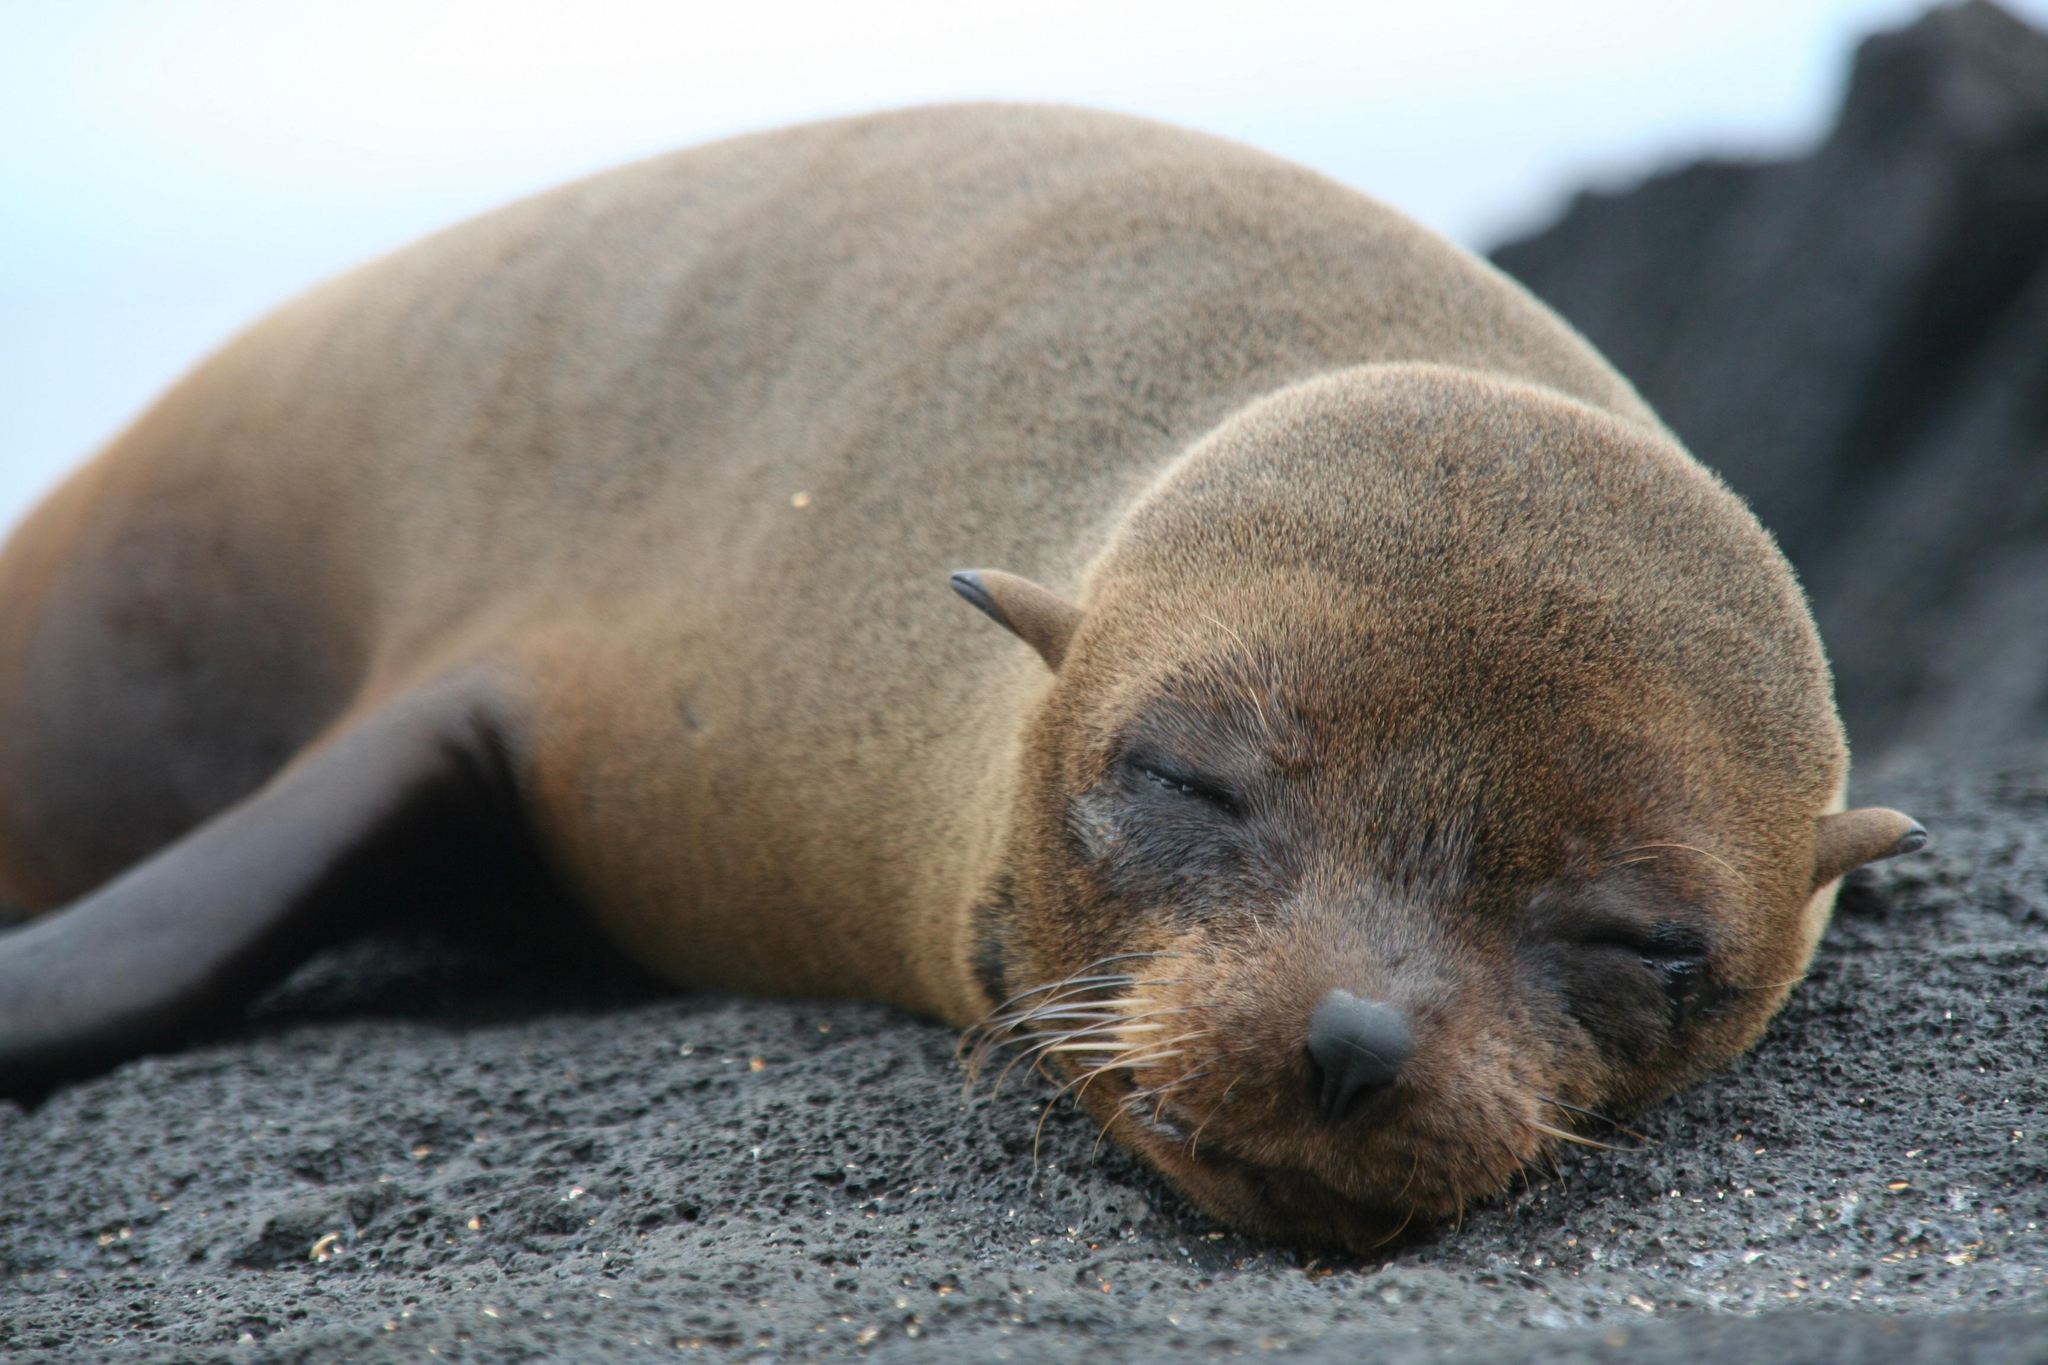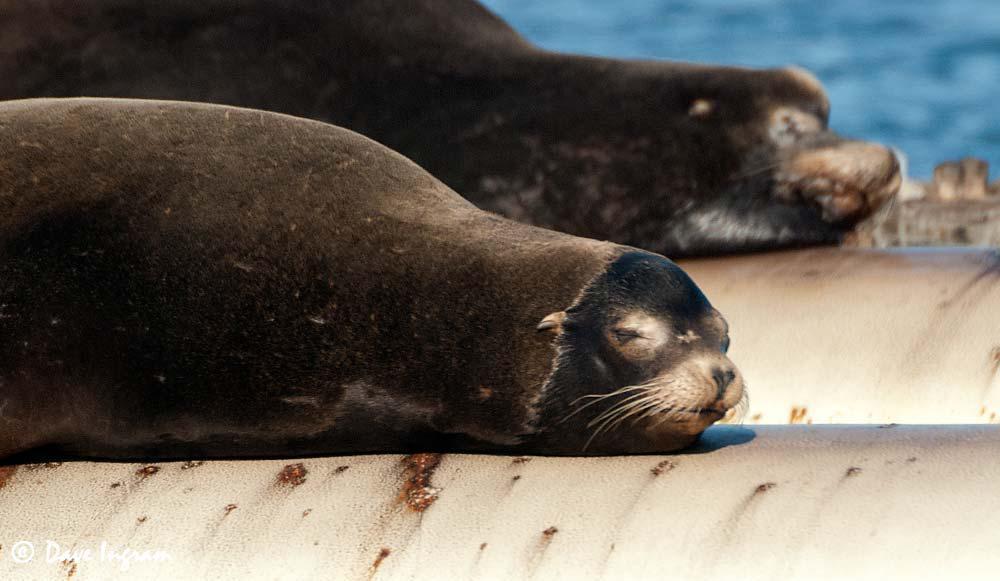The first image is the image on the left, the second image is the image on the right. Analyze the images presented: Is the assertion "A single seal is sunning on a rock in the image on the left." valid? Answer yes or no. Yes. 